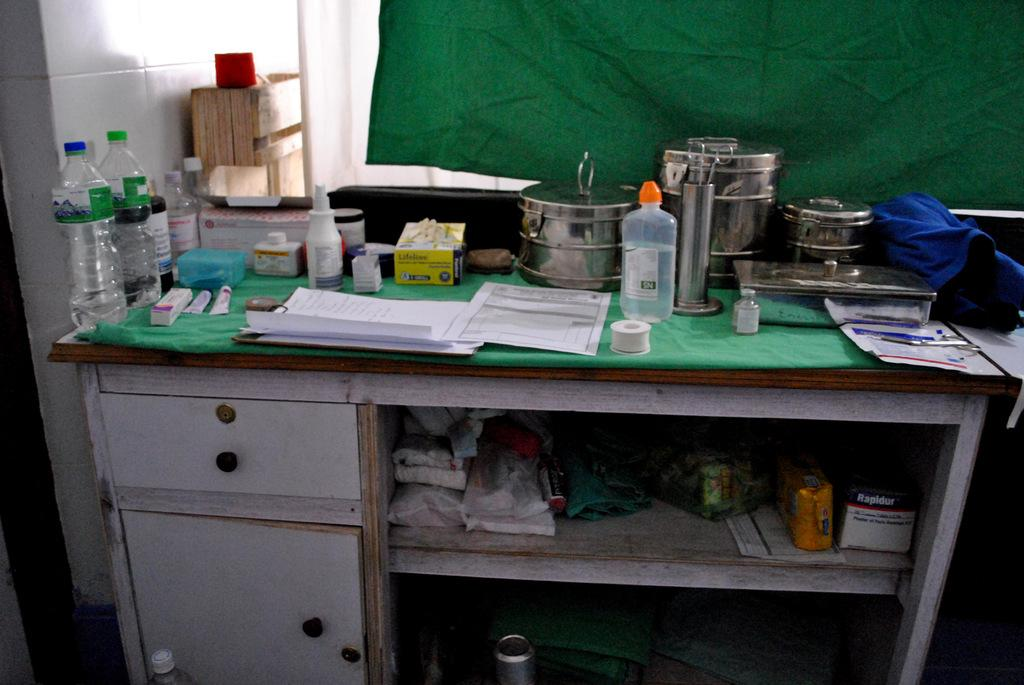What is located in the foreground of the image? There is a table in the foreground of the image. What items can be seen on the table? Bottles, tubes, papers, boxes, tape, and scissors are on the table. What can be seen in the background of the image? There is a green curtain and a wall in the background of the image. What type of patch can be seen on the earth in the image? There is no earth or patch present in the image; it features a table with various items and a green curtain in the background. What shape is the circle that is drawn on the wall in the image? There is no circle drawn on the wall in the image; it only features a green curtain and a wall in the background. 